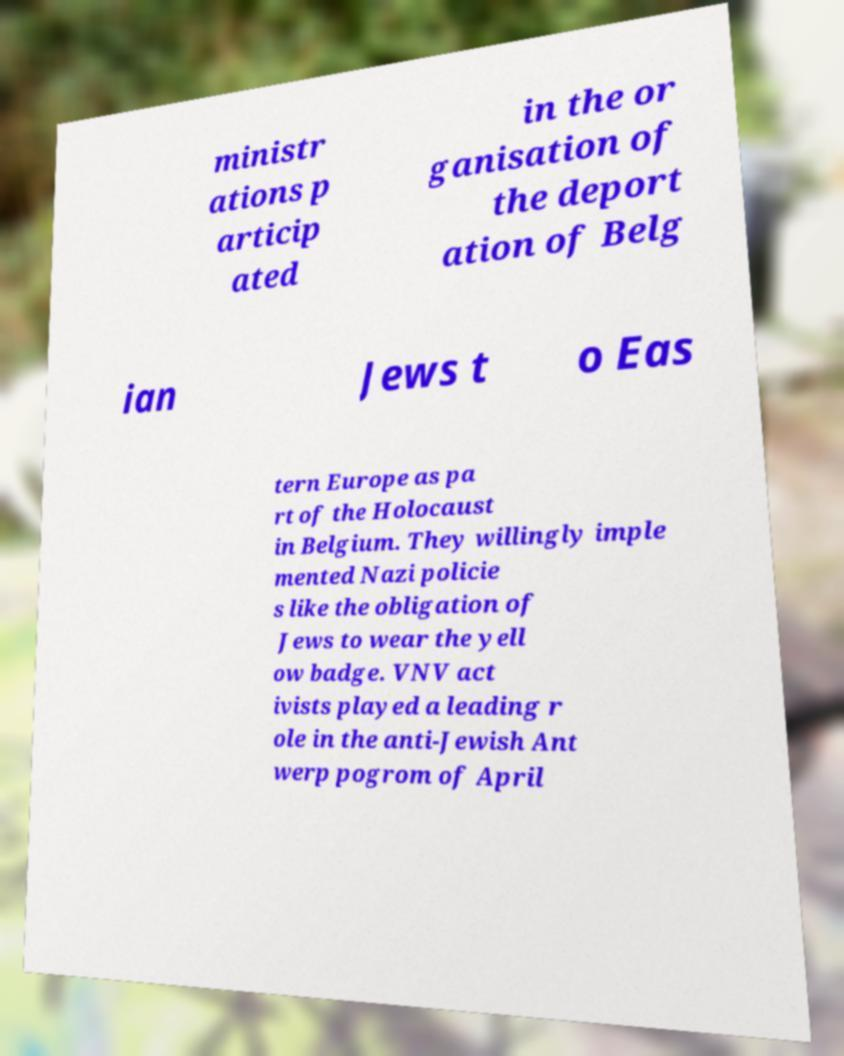Could you extract and type out the text from this image? ministr ations p articip ated in the or ganisation of the deport ation of Belg ian Jews t o Eas tern Europe as pa rt of the Holocaust in Belgium. They willingly imple mented Nazi policie s like the obligation of Jews to wear the yell ow badge. VNV act ivists played a leading r ole in the anti-Jewish Ant werp pogrom of April 